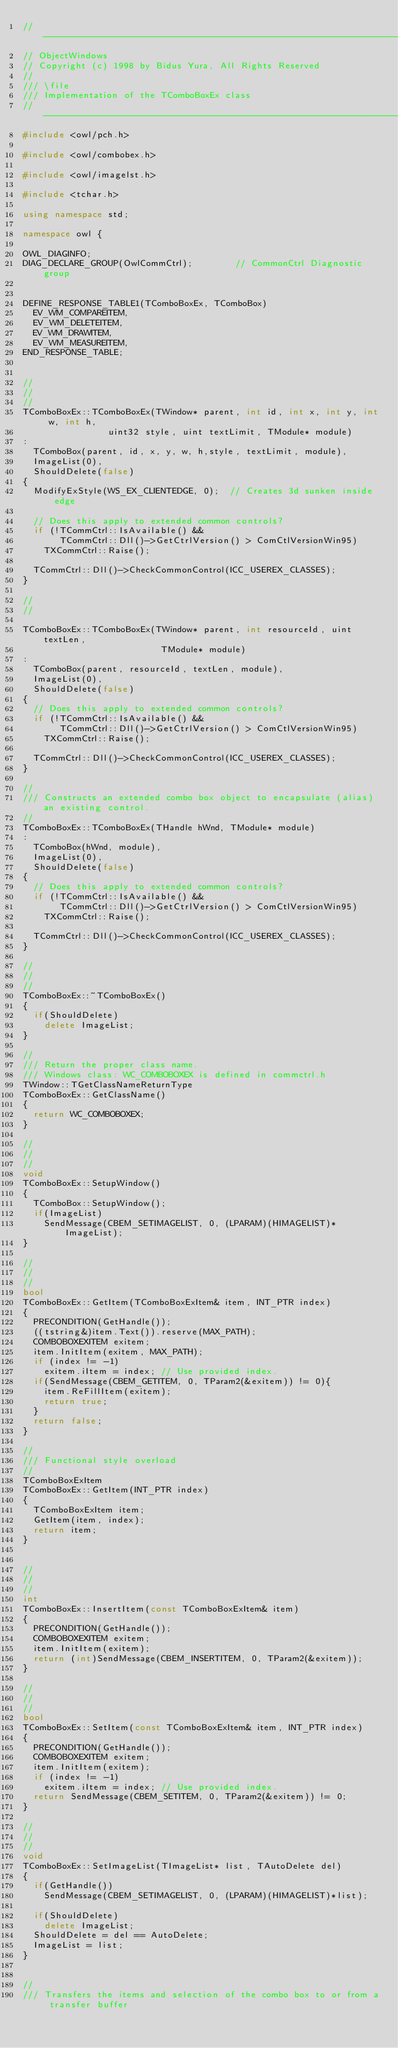<code> <loc_0><loc_0><loc_500><loc_500><_C++_>//----------------------------------------------------------------------------
// ObjectWindows
// Copyright (c) 1998 by Bidus Yura, All Rights Reserved
//
/// \file
/// Implementation of the TComboBoxEx class
//----------------------------------------------------------------------------
#include <owl/pch.h>

#include <owl/combobex.h>

#include <owl/imagelst.h>

#include <tchar.h>

using namespace std;

namespace owl {

OWL_DIAGINFO;
DIAG_DECLARE_GROUP(OwlCommCtrl);        // CommonCtrl Diagnostic group


DEFINE_RESPONSE_TABLE1(TComboBoxEx, TComboBox)
  EV_WM_COMPAREITEM,
  EV_WM_DELETEITEM,
  EV_WM_DRAWITEM,
  EV_WM_MEASUREITEM,
END_RESPONSE_TABLE;


//
//
//
TComboBoxEx::TComboBoxEx(TWindow* parent, int id, int x, int y, int w, int h,
                uint32 style, uint textLimit, TModule* module)
:
  TComboBox(parent, id, x, y, w, h,style, textLimit, module),
  ImageList(0),
  ShouldDelete(false)
{
  ModifyExStyle(WS_EX_CLIENTEDGE, 0);  // Creates 3d sunken inside edge

  // Does this apply to extended common controls?
  if (!TCommCtrl::IsAvailable() &&
       TCommCtrl::Dll()->GetCtrlVersion() > ComCtlVersionWin95)
    TXCommCtrl::Raise();

  TCommCtrl::Dll()->CheckCommonControl(ICC_USEREX_CLASSES);
}

//
//

TComboBoxEx::TComboBoxEx(TWindow* parent, int resourceId, uint textLen,
                          TModule* module)
:
  TComboBox(parent, resourceId, textLen, module),
  ImageList(0),
  ShouldDelete(false)
{
  // Does this apply to extended common controls?
  if (!TCommCtrl::IsAvailable() &&
       TCommCtrl::Dll()->GetCtrlVersion() > ComCtlVersionWin95)
    TXCommCtrl::Raise();

  TCommCtrl::Dll()->CheckCommonControl(ICC_USEREX_CLASSES);
}

//
/// Constructs an extended combo box object to encapsulate (alias) an existing control.
// 
TComboBoxEx::TComboBoxEx(THandle hWnd, TModule* module)
:
  TComboBox(hWnd, module),
  ImageList(0),
  ShouldDelete(false)
{
  // Does this apply to extended common controls?
  if (!TCommCtrl::IsAvailable() &&
       TCommCtrl::Dll()->GetCtrlVersion() > ComCtlVersionWin95)
    TXCommCtrl::Raise();

  TCommCtrl::Dll()->CheckCommonControl(ICC_USEREX_CLASSES);
}

//
//
//
TComboBoxEx::~TComboBoxEx()
{
  if(ShouldDelete)
    delete ImageList;
}

//
/// Return the proper class name.
/// Windows class: WC_COMBOBOXEX is defined in commctrl.h
TWindow::TGetClassNameReturnType
TComboBoxEx::GetClassName()
{
  return WC_COMBOBOXEX;
}

//
//
//
void
TComboBoxEx::SetupWindow()
{
  TComboBox::SetupWindow();
  if(ImageList)
    SendMessage(CBEM_SETIMAGELIST, 0, (LPARAM)(HIMAGELIST)*ImageList);
}

//
//
//
bool
TComboBoxEx::GetItem(TComboBoxExItem& item, INT_PTR index)
{
  PRECONDITION(GetHandle());
  ((tstring&)item.Text()).reserve(MAX_PATH);
  COMBOBOXEXITEM exitem;
  item.InitItem(exitem, MAX_PATH);
  if (index != -1)
    exitem.iItem = index; // Use provided index.
  if(SendMessage(CBEM_GETITEM, 0, TParam2(&exitem)) != 0){
    item.ReFillItem(exitem);
    return true;
  }
  return false;
}

//
/// Functional style overload
//
TComboBoxExItem 
TComboBoxEx::GetItem(INT_PTR index) 
{
  TComboBoxExItem item; 
  GetItem(item, index); 
  return item;
}


//
//
//
int
TComboBoxEx::InsertItem(const TComboBoxExItem& item)
{
  PRECONDITION(GetHandle());
  COMBOBOXEXITEM exitem;
  item.InitItem(exitem);
  return (int)SendMessage(CBEM_INSERTITEM, 0, TParam2(&exitem));
}

//
//
//
bool
TComboBoxEx::SetItem(const TComboBoxExItem& item, INT_PTR index)
{
  PRECONDITION(GetHandle());
  COMBOBOXEXITEM exitem;
  item.InitItem(exitem);
  if (index != -1)
    exitem.iItem = index; // Use provided index.
  return SendMessage(CBEM_SETITEM, 0, TParam2(&exitem)) != 0;
}

//
//
//
void
TComboBoxEx::SetImageList(TImageList* list, TAutoDelete del)
{
  if(GetHandle())
    SendMessage(CBEM_SETIMAGELIST, 0, (LPARAM)(HIMAGELIST)*list);

  if(ShouldDelete)
    delete ImageList;
  ShouldDelete = del == AutoDelete;
  ImageList = list;
}


//
/// Transfers the items and selection of the combo box to or from a transfer buffer</code> 